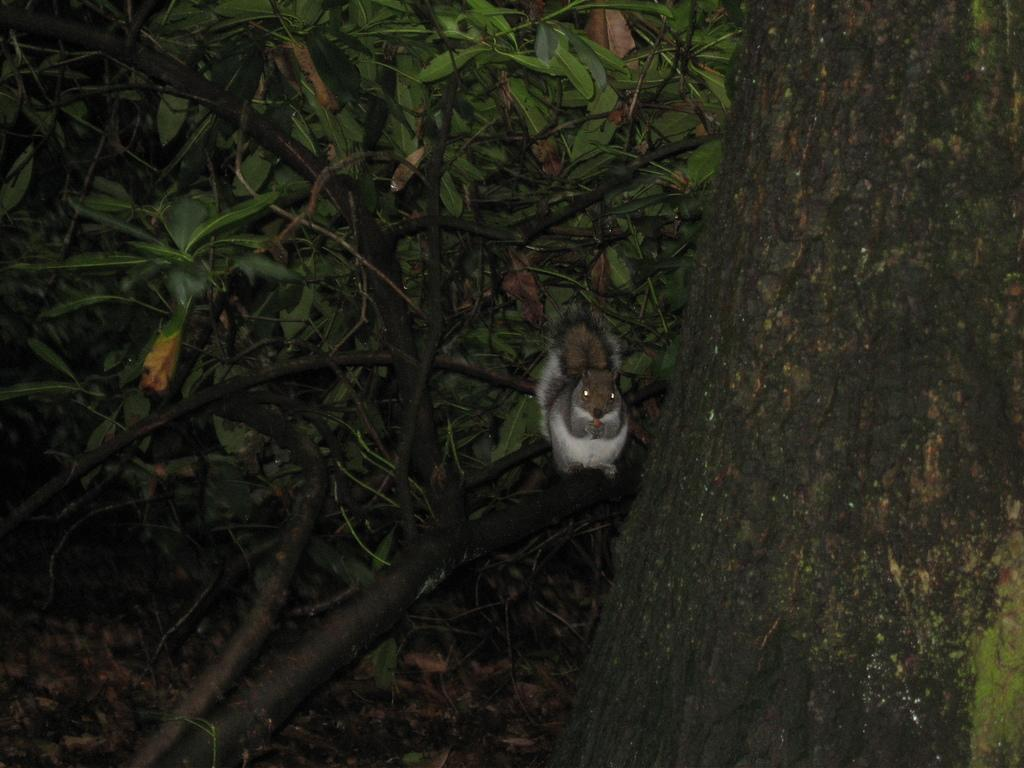What is present in the image? There is an animal in the image. Where is the animal located? The animal is on a tree. What color is the sweater the animal is wearing in the image? There is no sweater present in the image, as the animal is on a tree and not wearing any clothing. 